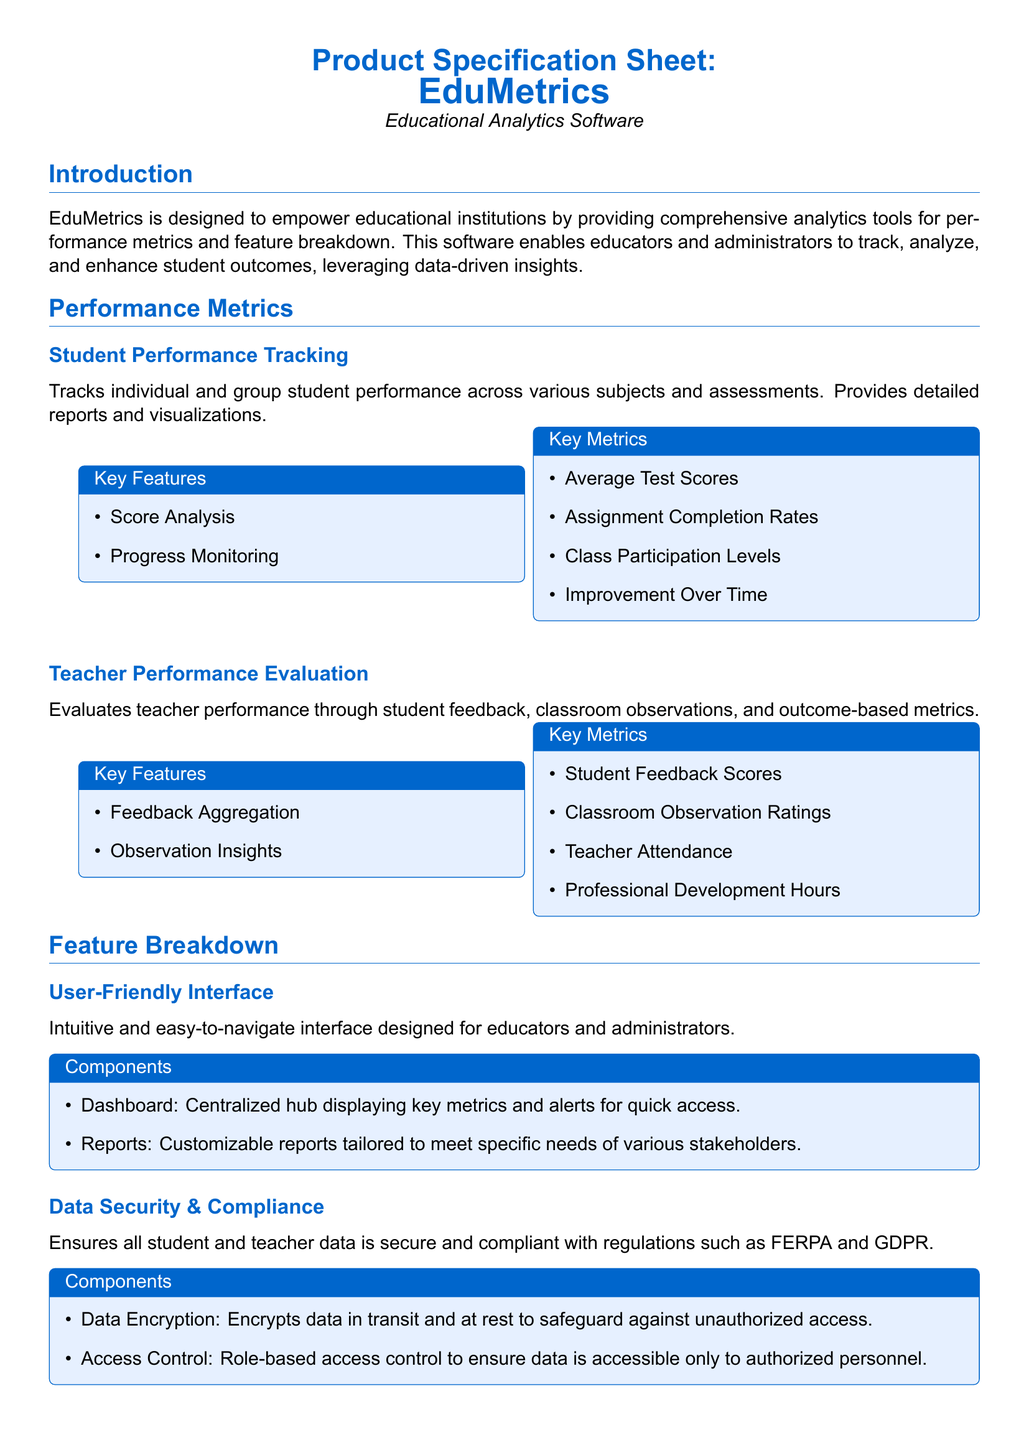What is the name of the software? The name of the software is stated in the title section of the document.
Answer: EduMetrics What type of software is EduMetrics? The type of software is specified immediately after the name in the document.
Answer: Educational Analytics Software What are the key metrics for Student Performance Tracking? The key metrics are listed under the Student Performance Tracking section of the document.
Answer: Average Test Scores, Assignment Completion Rates, Class Participation Levels, Improvement Over Time How many key features are listed for Teacher Performance Evaluation? The key features are counted from the corresponding list in the document.
Answer: Two Which compliance regulations does EduMetrics adhere to? The regulations are mentioned in the Data Security & Compliance section.
Answer: FERPA and GDPR What integration capabilities are highlighted in the document? The integration capabilities are listed in the corresponding section of the document.
Answer: LMS Integration, API Access What is the phone number for EduMetrics Inc.? The phone number is provided in the contact information section at the bottom of the document.
Answer: +1-800-123-4567 What component is described as a centralized hub? The component is specifically mentioned in the User-Friendly Interface section of the document.
Answer: Dashboard What is the purpose of Data Encryption mentioned in the document? The purpose of Data Encryption is explained in the Data Security & Compliance section.
Answer: To safeguard against unauthorized access 